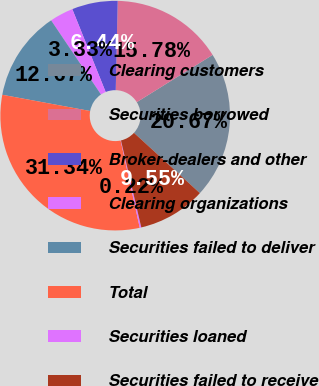Convert chart to OTSL. <chart><loc_0><loc_0><loc_500><loc_500><pie_chart><fcel>Clearing customers<fcel>Securities borrowed<fcel>Broker-dealers and other<fcel>Clearing organizations<fcel>Securities failed to deliver<fcel>Total<fcel>Securities loaned<fcel>Securities failed to receive<nl><fcel>20.67%<fcel>15.78%<fcel>6.44%<fcel>3.33%<fcel>12.67%<fcel>31.34%<fcel>0.22%<fcel>9.55%<nl></chart> 